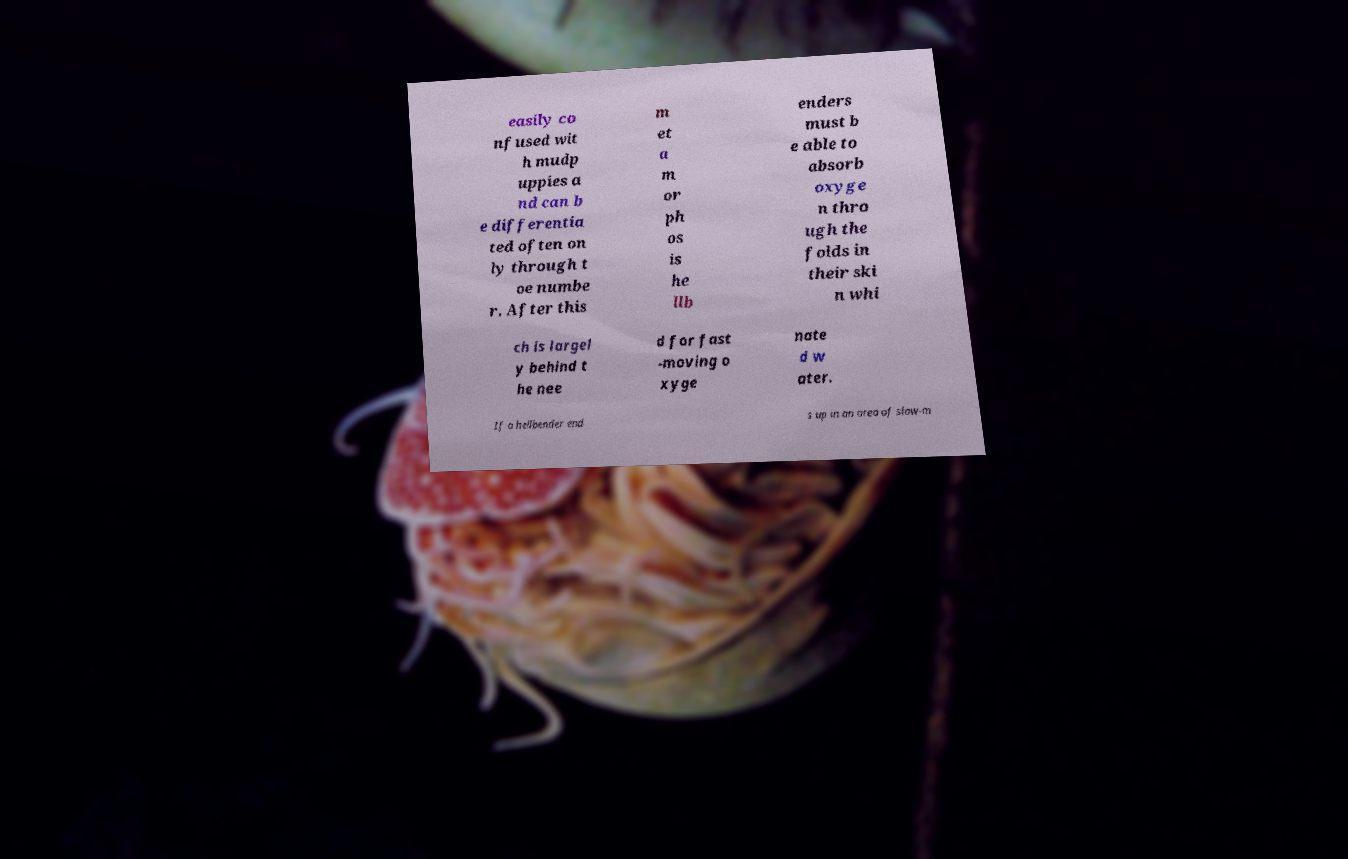For documentation purposes, I need the text within this image transcribed. Could you provide that? easily co nfused wit h mudp uppies a nd can b e differentia ted often on ly through t oe numbe r. After this m et a m or ph os is he llb enders must b e able to absorb oxyge n thro ugh the folds in their ski n whi ch is largel y behind t he nee d for fast -moving o xyge nate d w ater. If a hellbender end s up in an area of slow-m 